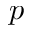<formula> <loc_0><loc_0><loc_500><loc_500>p</formula> 